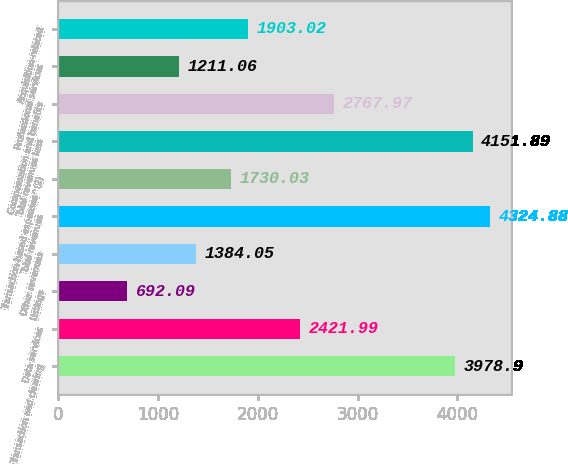<chart> <loc_0><loc_0><loc_500><loc_500><bar_chart><fcel>Transaction and clearing<fcel>Data services<fcel>Listings<fcel>Other revenues<fcel>Total revenues<fcel>Transaction-based expenses^(2)<fcel>Total revenues less<fcel>Compensation and benefits<fcel>Professional services<fcel>Acquisition-related<nl><fcel>3978.9<fcel>2421.99<fcel>692.09<fcel>1384.05<fcel>4324.88<fcel>1730.03<fcel>4151.89<fcel>2767.97<fcel>1211.06<fcel>1903.02<nl></chart> 